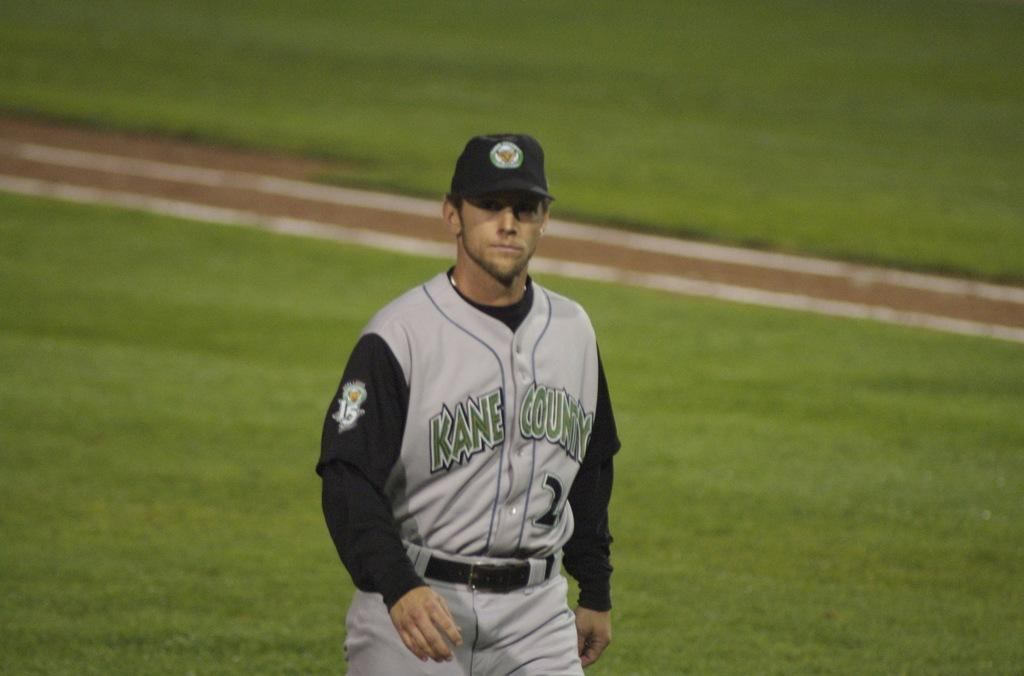<image>
Provide a brief description of the given image. A baseball player with Kane County on his shirt 